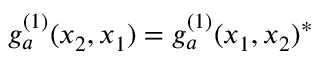Convert formula to latex. <formula><loc_0><loc_0><loc_500><loc_500>g _ { a } ^ { ( 1 ) } ( x _ { 2 } , x _ { 1 } ) = g _ { a } ^ { ( 1 ) } ( x _ { 1 } , x _ { 2 } ) ^ { * }</formula> 